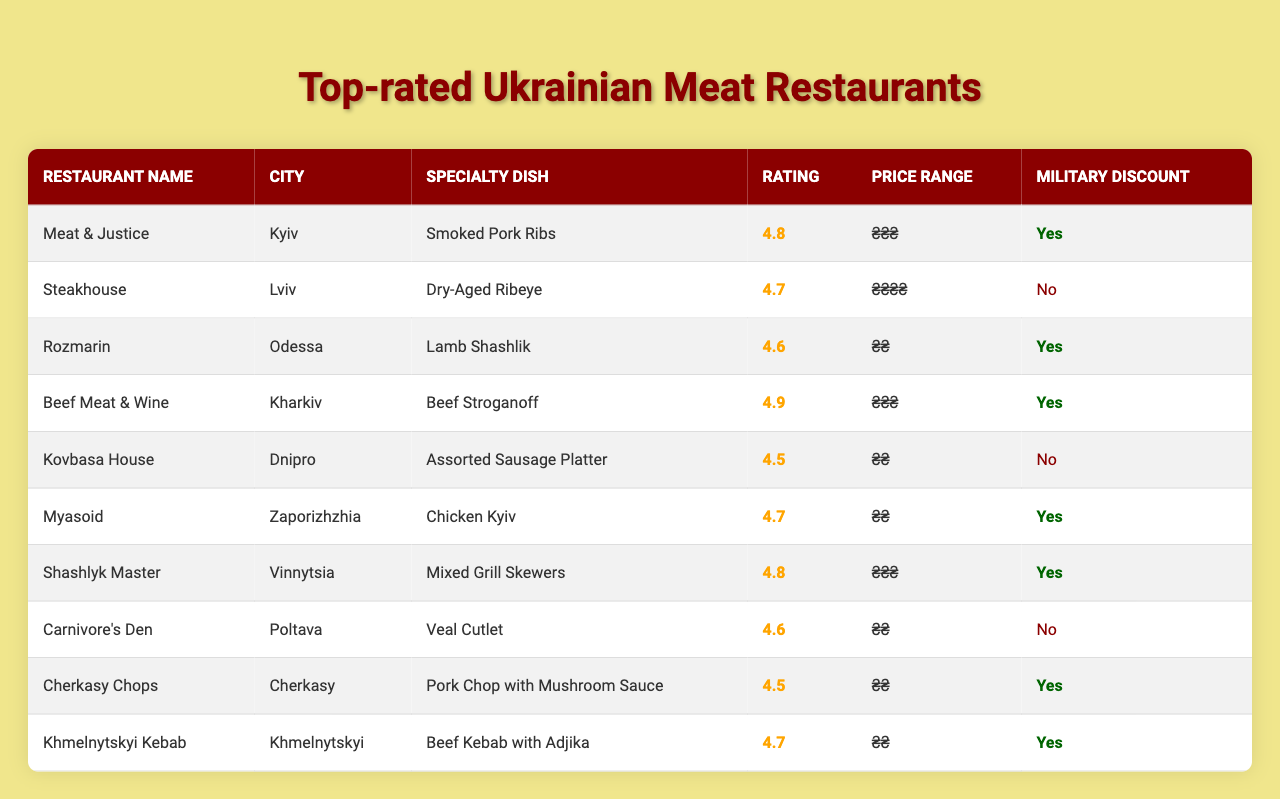What is the highest-rated restaurant in Kyiv? The table lists "Meat & Justice" with a rating of 4.8 as the highest-rated restaurant located in Kyiv.
Answer: Meat & Justice Which restaurant in Lviv serves the specialty dish of Dry-Aged Ribeye? The table specifies "Steakhouse" in Lviv as serving the specialty dish of Dry-Aged Ribeye.
Answer: Steakhouse How many restaurants offer a military discount? There are 6 restaurants that offer a military discount, which can be counted by looking for "Yes" in the Military Discount column.
Answer: 6 What is the specialty dish offered by the restaurant "Rozmarin" in Odessa? The table indicates that "Rozmarin" serves Lamb Shashlik as its specialty dish in Odessa.
Answer: Lamb Shashlik Which city has a restaurant with the specialty dish of Assorted Sausage Platter? The table shows that "Kovbasa House" in Dnipro offers Assorted Sausage Platter as its specialty dish.
Answer: Dnipro What is the average rating of the restaurants listed in this table? The ratings are: 4.8, 4.7, 4.6, 4.9, 4.5, 4.7, 4.8, 4.6, 4.5, 4.7. Summing these gives 46.8, and dividing by 10 gives an average rating of 4.68.
Answer: 4.68 Which restaurant has the lowest rating among those that provide a military discount? From the table, "Cherkasy Chops" has a rating of 4.5 and provides a military discount, which is lower than the others that do.
Answer: Cherkasy Chops In which city can you find the restaurant "Shashlyk Master"? The table shows that "Shashlyk Master" is located in Vinnytsia.
Answer: Vinnytsia Are there any restaurants in Poltava that offer military discounts? The table indicates that "Carnivore's Den" in Poltava does not offer a military discount, therefore there are no restaurants in Poltava with military discounts.
Answer: No What is the price range for the highest-rated restaurant, Beef Meat & Wine? The table indicates that "Beef Meat & Wine" has a price range of ₴₴₴, which is the same as "Meat & Justice" that also has a high rating.
Answer: ₴₴₴ 